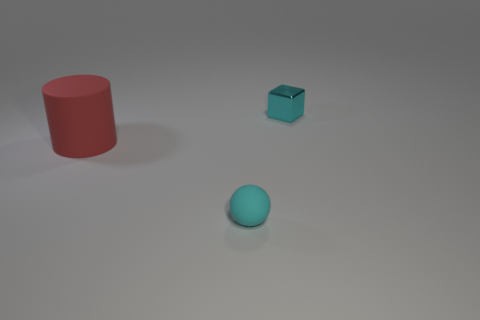Add 1 small gray metallic cylinders. How many objects exist? 4 Subtract all spheres. How many objects are left? 2 Add 3 yellow matte balls. How many yellow matte balls exist? 3 Subtract 0 yellow spheres. How many objects are left? 3 Subtract all small purple blocks. Subtract all spheres. How many objects are left? 2 Add 2 large red matte things. How many large red matte things are left? 3 